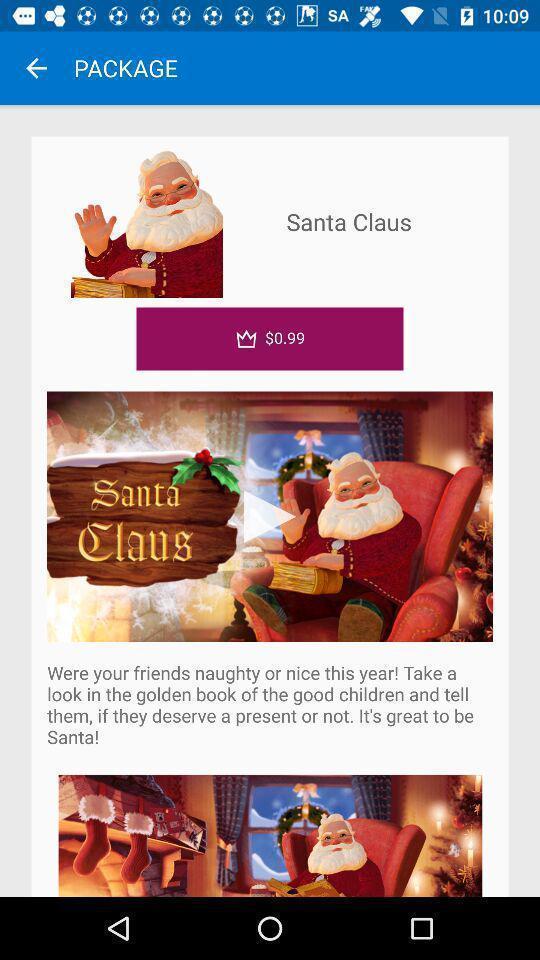Describe the visual elements of this screenshot. Screen shows about a package from santa. 